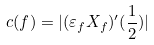<formula> <loc_0><loc_0><loc_500><loc_500>c ( f ) = | ( \varepsilon _ { f } X _ { f } ) ^ { \prime } ( \frac { 1 } { 2 } ) |</formula> 